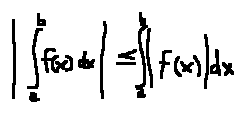Convert formula to latex. <formula><loc_0><loc_0><loc_500><loc_500>| \int \lim i t s _ { a } ^ { b } f ( x ) d x | \leq \int \lim i t s _ { a } ^ { b } | f ( x ) | d x</formula> 